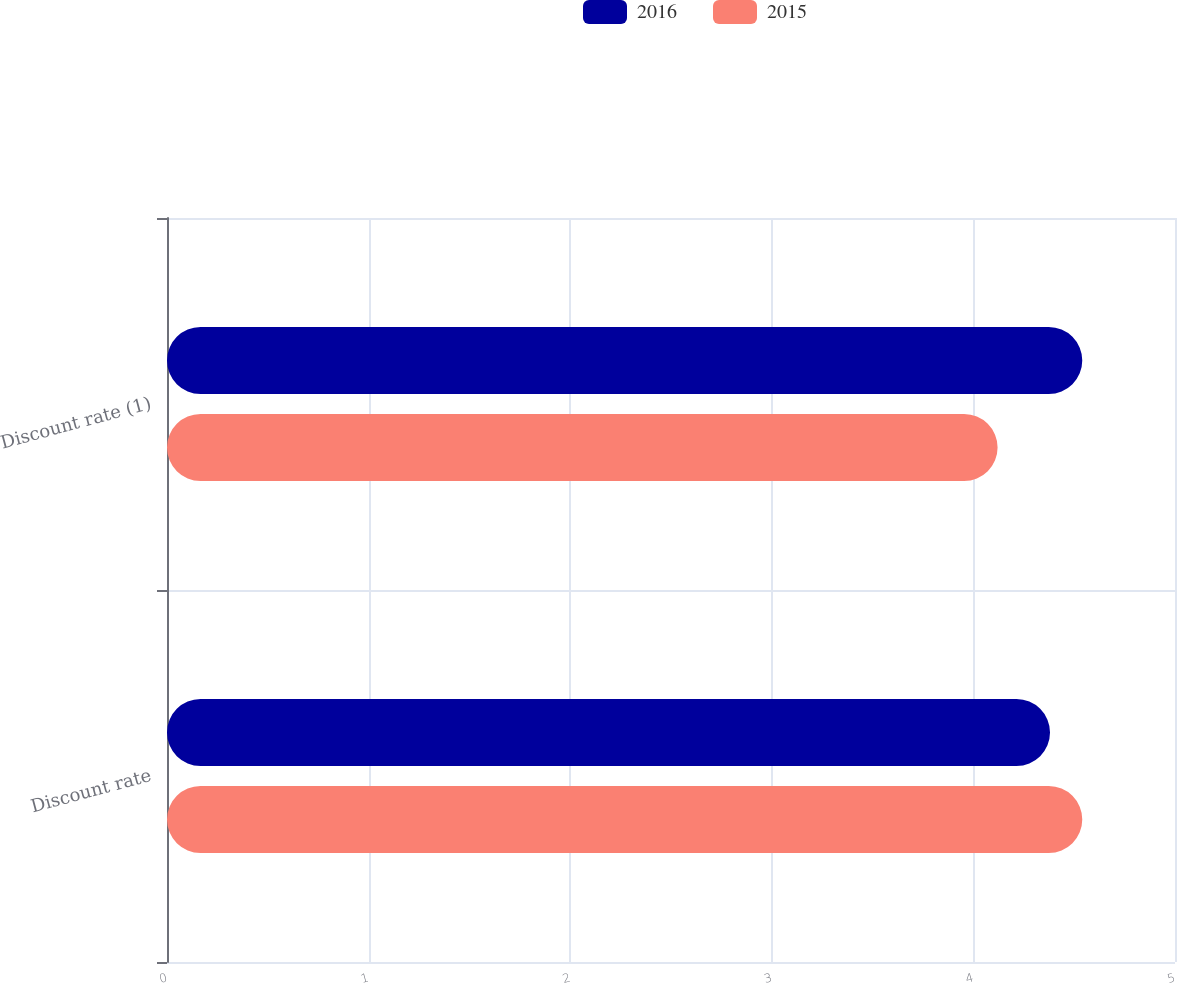Convert chart to OTSL. <chart><loc_0><loc_0><loc_500><loc_500><stacked_bar_chart><ecel><fcel>Discount rate<fcel>Discount rate (1)<nl><fcel>2016<fcel>4.38<fcel>4.54<nl><fcel>2015<fcel>4.54<fcel>4.12<nl></chart> 